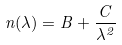<formula> <loc_0><loc_0><loc_500><loc_500>n ( \lambda ) = B + \frac { C } { \lambda ^ { 2 } }</formula> 